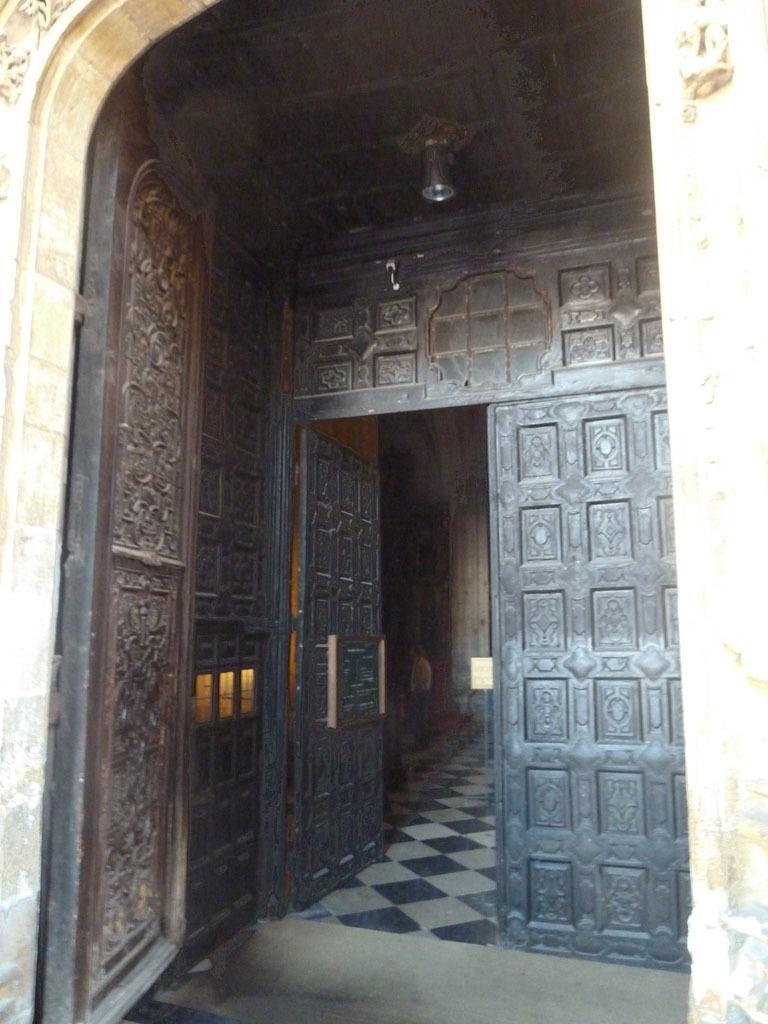Please provide a concise description of this image. In this picture I can see black color doors and light attached to the ceiling. Here I can see floor. 